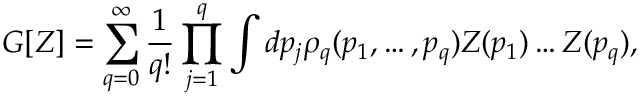Convert formula to latex. <formula><loc_0><loc_0><loc_500><loc_500>G [ Z ] = \sum _ { q = 0 } ^ { \infty } \frac { 1 } { q ! } \prod _ { j = 1 } ^ { q } \int d p _ { j } \rho _ { q } ( p _ { 1 } , \dots , p _ { q } ) Z ( p _ { 1 } ) \dots Z ( p _ { q } ) ,</formula> 